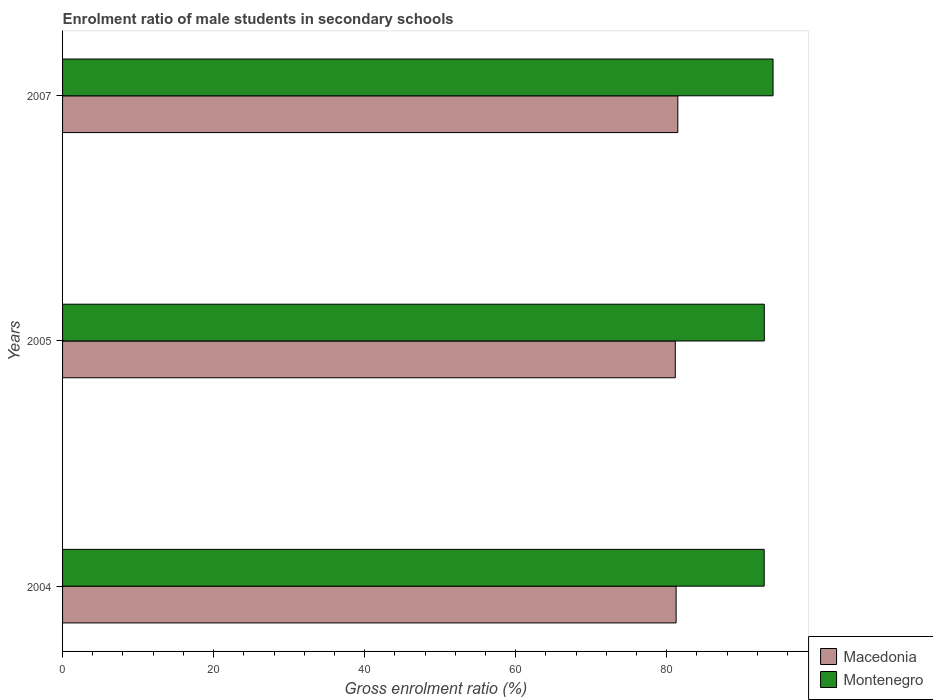Are the number of bars on each tick of the Y-axis equal?
Provide a succinct answer. Yes. What is the label of the 3rd group of bars from the top?
Your response must be concise. 2004. In how many cases, is the number of bars for a given year not equal to the number of legend labels?
Give a very brief answer. 0. What is the enrolment ratio of male students in secondary schools in Montenegro in 2005?
Your response must be concise. 92.92. Across all years, what is the maximum enrolment ratio of male students in secondary schools in Montenegro?
Your answer should be compact. 94.07. Across all years, what is the minimum enrolment ratio of male students in secondary schools in Montenegro?
Your response must be concise. 92.9. In which year was the enrolment ratio of male students in secondary schools in Macedonia minimum?
Your answer should be compact. 2005. What is the total enrolment ratio of male students in secondary schools in Macedonia in the graph?
Make the answer very short. 243.83. What is the difference between the enrolment ratio of male students in secondary schools in Macedonia in 2004 and that in 2005?
Make the answer very short. 0.11. What is the difference between the enrolment ratio of male students in secondary schools in Macedonia in 2004 and the enrolment ratio of male students in secondary schools in Montenegro in 2007?
Ensure brevity in your answer.  -12.83. What is the average enrolment ratio of male students in secondary schools in Montenegro per year?
Offer a terse response. 93.3. In the year 2005, what is the difference between the enrolment ratio of male students in secondary schools in Macedonia and enrolment ratio of male students in secondary schools in Montenegro?
Give a very brief answer. -11.79. In how many years, is the enrolment ratio of male students in secondary schools in Montenegro greater than 8 %?
Offer a terse response. 3. What is the ratio of the enrolment ratio of male students in secondary schools in Macedonia in 2004 to that in 2007?
Your response must be concise. 1. Is the enrolment ratio of male students in secondary schools in Macedonia in 2004 less than that in 2005?
Provide a succinct answer. No. Is the difference between the enrolment ratio of male students in secondary schools in Macedonia in 2005 and 2007 greater than the difference between the enrolment ratio of male students in secondary schools in Montenegro in 2005 and 2007?
Your answer should be compact. Yes. What is the difference between the highest and the second highest enrolment ratio of male students in secondary schools in Macedonia?
Your answer should be very brief. 0.22. What is the difference between the highest and the lowest enrolment ratio of male students in secondary schools in Macedonia?
Offer a terse response. 0.33. In how many years, is the enrolment ratio of male students in secondary schools in Macedonia greater than the average enrolment ratio of male students in secondary schools in Macedonia taken over all years?
Keep it short and to the point. 1. What does the 2nd bar from the top in 2007 represents?
Give a very brief answer. Macedonia. What does the 1st bar from the bottom in 2004 represents?
Your answer should be compact. Macedonia. How many bars are there?
Ensure brevity in your answer.  6. Are the values on the major ticks of X-axis written in scientific E-notation?
Give a very brief answer. No. Does the graph contain grids?
Make the answer very short. No. Where does the legend appear in the graph?
Ensure brevity in your answer.  Bottom right. How many legend labels are there?
Make the answer very short. 2. How are the legend labels stacked?
Your response must be concise. Vertical. What is the title of the graph?
Your answer should be very brief. Enrolment ratio of male students in secondary schools. Does "Upper middle income" appear as one of the legend labels in the graph?
Provide a succinct answer. No. What is the label or title of the X-axis?
Provide a short and direct response. Gross enrolment ratio (%). What is the label or title of the Y-axis?
Your answer should be very brief. Years. What is the Gross enrolment ratio (%) of Macedonia in 2004?
Make the answer very short. 81.24. What is the Gross enrolment ratio (%) of Montenegro in 2004?
Keep it short and to the point. 92.9. What is the Gross enrolment ratio (%) of Macedonia in 2005?
Your answer should be very brief. 81.13. What is the Gross enrolment ratio (%) of Montenegro in 2005?
Offer a terse response. 92.92. What is the Gross enrolment ratio (%) in Macedonia in 2007?
Offer a terse response. 81.46. What is the Gross enrolment ratio (%) of Montenegro in 2007?
Offer a very short reply. 94.07. Across all years, what is the maximum Gross enrolment ratio (%) in Macedonia?
Provide a short and direct response. 81.46. Across all years, what is the maximum Gross enrolment ratio (%) in Montenegro?
Provide a short and direct response. 94.07. Across all years, what is the minimum Gross enrolment ratio (%) of Macedonia?
Offer a terse response. 81.13. Across all years, what is the minimum Gross enrolment ratio (%) in Montenegro?
Provide a succinct answer. 92.9. What is the total Gross enrolment ratio (%) of Macedonia in the graph?
Your answer should be compact. 243.83. What is the total Gross enrolment ratio (%) of Montenegro in the graph?
Your response must be concise. 279.89. What is the difference between the Gross enrolment ratio (%) of Macedonia in 2004 and that in 2005?
Make the answer very short. 0.11. What is the difference between the Gross enrolment ratio (%) of Montenegro in 2004 and that in 2005?
Offer a terse response. -0.01. What is the difference between the Gross enrolment ratio (%) of Macedonia in 2004 and that in 2007?
Your response must be concise. -0.22. What is the difference between the Gross enrolment ratio (%) in Montenegro in 2004 and that in 2007?
Offer a terse response. -1.17. What is the difference between the Gross enrolment ratio (%) in Macedonia in 2005 and that in 2007?
Provide a succinct answer. -0.33. What is the difference between the Gross enrolment ratio (%) in Montenegro in 2005 and that in 2007?
Ensure brevity in your answer.  -1.16. What is the difference between the Gross enrolment ratio (%) in Macedonia in 2004 and the Gross enrolment ratio (%) in Montenegro in 2005?
Provide a succinct answer. -11.68. What is the difference between the Gross enrolment ratio (%) in Macedonia in 2004 and the Gross enrolment ratio (%) in Montenegro in 2007?
Ensure brevity in your answer.  -12.83. What is the difference between the Gross enrolment ratio (%) of Macedonia in 2005 and the Gross enrolment ratio (%) of Montenegro in 2007?
Offer a very short reply. -12.94. What is the average Gross enrolment ratio (%) in Macedonia per year?
Provide a short and direct response. 81.28. What is the average Gross enrolment ratio (%) in Montenegro per year?
Ensure brevity in your answer.  93.3. In the year 2004, what is the difference between the Gross enrolment ratio (%) of Macedonia and Gross enrolment ratio (%) of Montenegro?
Ensure brevity in your answer.  -11.66. In the year 2005, what is the difference between the Gross enrolment ratio (%) in Macedonia and Gross enrolment ratio (%) in Montenegro?
Your answer should be very brief. -11.79. In the year 2007, what is the difference between the Gross enrolment ratio (%) of Macedonia and Gross enrolment ratio (%) of Montenegro?
Give a very brief answer. -12.61. What is the ratio of the Gross enrolment ratio (%) in Macedonia in 2004 to that in 2007?
Provide a succinct answer. 1. What is the ratio of the Gross enrolment ratio (%) in Montenegro in 2004 to that in 2007?
Your answer should be very brief. 0.99. What is the difference between the highest and the second highest Gross enrolment ratio (%) in Macedonia?
Your answer should be compact. 0.22. What is the difference between the highest and the second highest Gross enrolment ratio (%) in Montenegro?
Your answer should be compact. 1.16. What is the difference between the highest and the lowest Gross enrolment ratio (%) of Macedonia?
Give a very brief answer. 0.33. What is the difference between the highest and the lowest Gross enrolment ratio (%) in Montenegro?
Your answer should be compact. 1.17. 